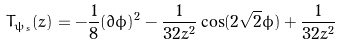<formula> <loc_0><loc_0><loc_500><loc_500>T _ { \psi _ { s } } ( z ) = - \frac { 1 } { 8 } ( \partial \phi ) ^ { 2 } - \frac { 1 } { 3 2 z ^ { 2 } } \cos ( 2 \sqrt { 2 } \phi ) + \frac { 1 } { 3 2 z ^ { 2 } }</formula> 